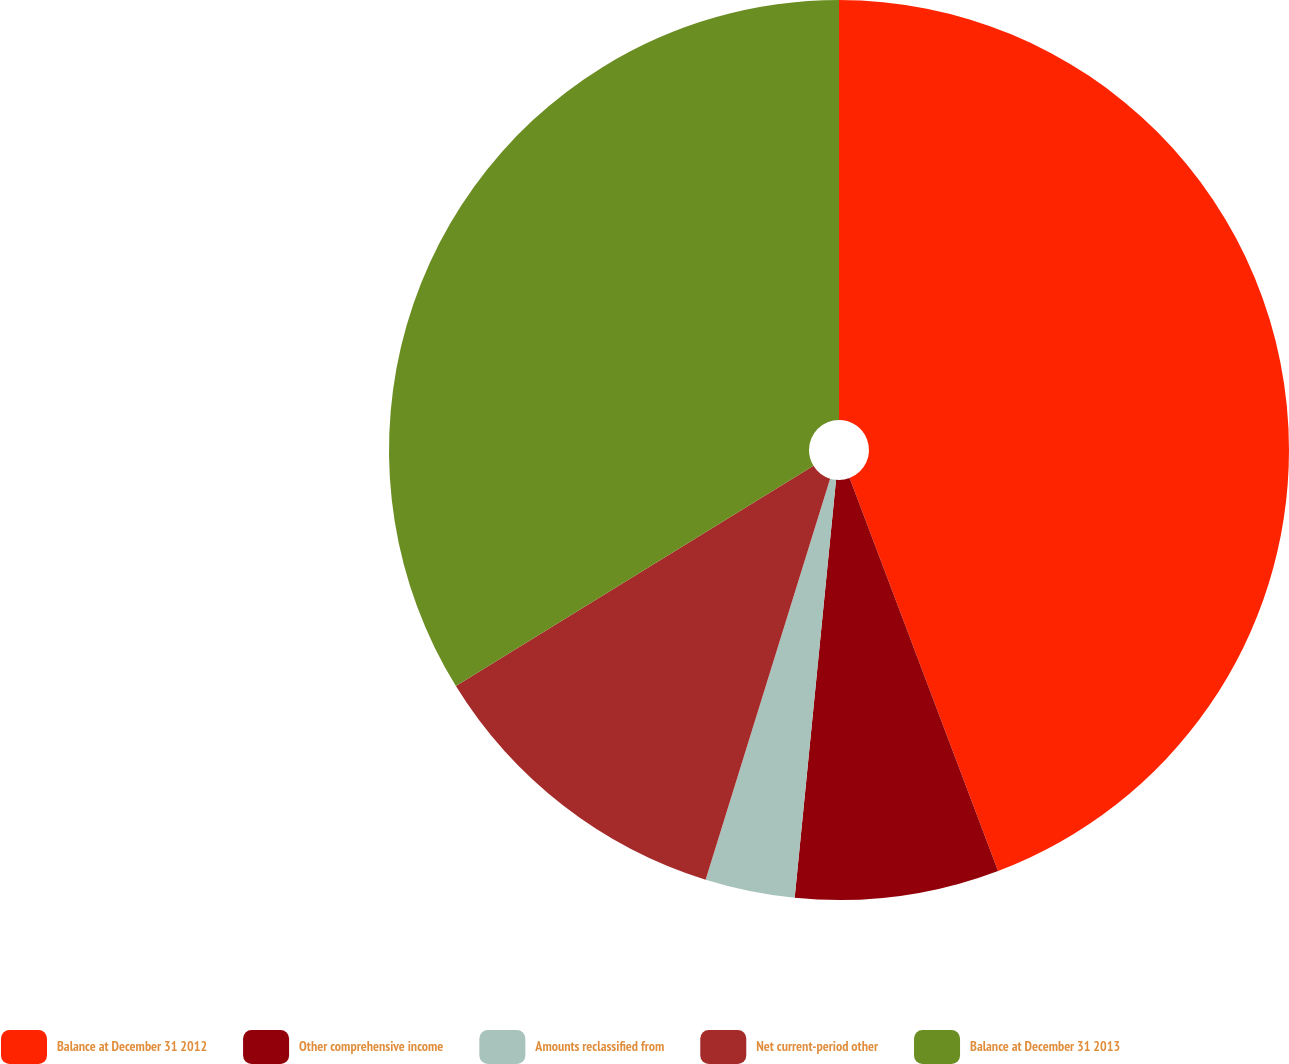Convert chart. <chart><loc_0><loc_0><loc_500><loc_500><pie_chart><fcel>Balance at December 31 2012<fcel>Other comprehensive income<fcel>Amounts reclassified from<fcel>Net current-period other<fcel>Balance at December 31 2013<nl><fcel>44.25%<fcel>7.32%<fcel>3.22%<fcel>11.42%<fcel>33.79%<nl></chart> 